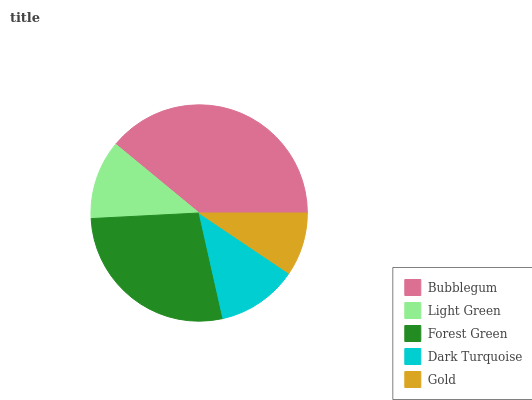Is Gold the minimum?
Answer yes or no. Yes. Is Bubblegum the maximum?
Answer yes or no. Yes. Is Light Green the minimum?
Answer yes or no. No. Is Light Green the maximum?
Answer yes or no. No. Is Bubblegum greater than Light Green?
Answer yes or no. Yes. Is Light Green less than Bubblegum?
Answer yes or no. Yes. Is Light Green greater than Bubblegum?
Answer yes or no. No. Is Bubblegum less than Light Green?
Answer yes or no. No. Is Dark Turquoise the high median?
Answer yes or no. Yes. Is Dark Turquoise the low median?
Answer yes or no. Yes. Is Bubblegum the high median?
Answer yes or no. No. Is Forest Green the low median?
Answer yes or no. No. 